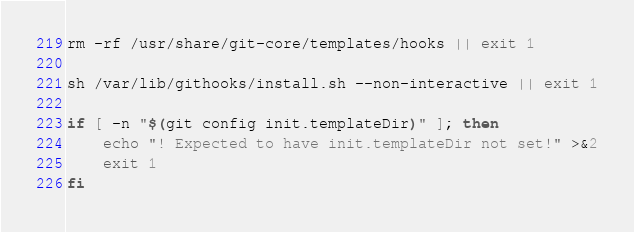<code> <loc_0><loc_0><loc_500><loc_500><_Bash_>rm -rf /usr/share/git-core/templates/hooks || exit 1

sh /var/lib/githooks/install.sh --non-interactive || exit 1

if [ -n "$(git config init.templateDir)" ]; then
    echo "! Expected to have init.templateDir not set!" >&2
    exit 1
fi
</code> 